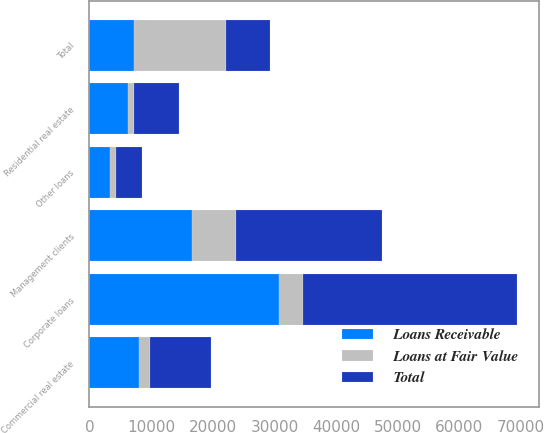<chart> <loc_0><loc_0><loc_500><loc_500><stacked_bar_chart><ecel><fcel>Corporate loans<fcel>Management clients<fcel>Commercial real estate<fcel>Residential real estate<fcel>Other loans<fcel>Total<nl><fcel>Loans Receivable<fcel>30749<fcel>16591<fcel>7987<fcel>6234<fcel>3263<fcel>7189.5<nl><fcel>Loans at Fair Value<fcel>3924<fcel>7102<fcel>1825<fcel>1043<fcel>983<fcel>14877<nl><fcel>Total<fcel>34673<fcel>23693<fcel>9812<fcel>7277<fcel>4246<fcel>7189.5<nl></chart> 